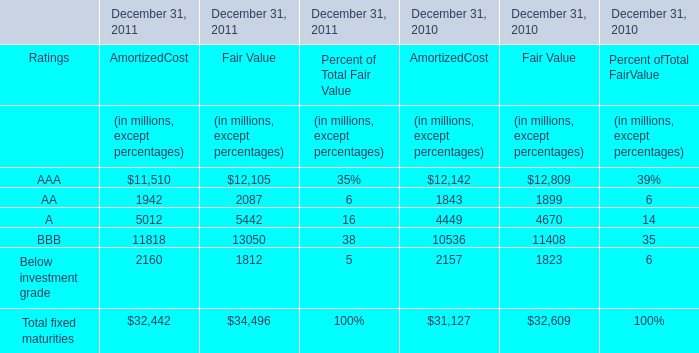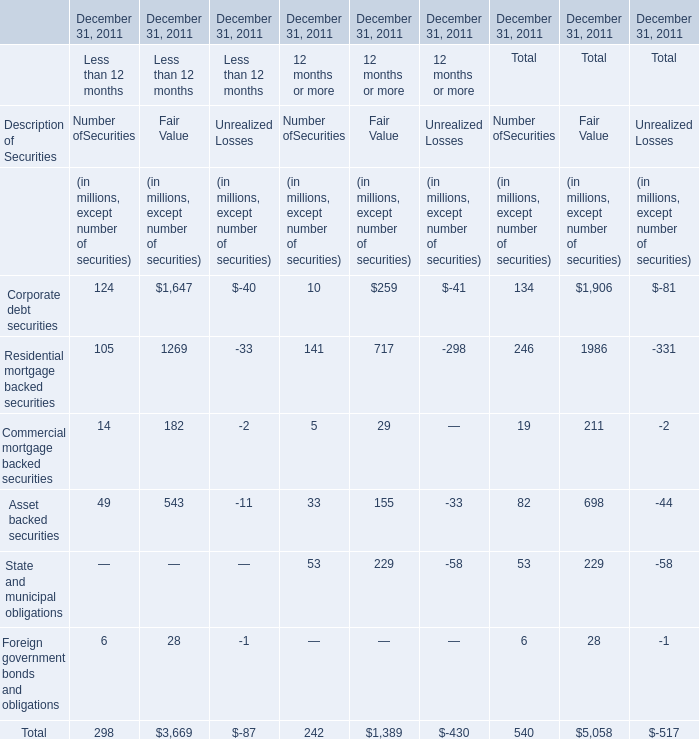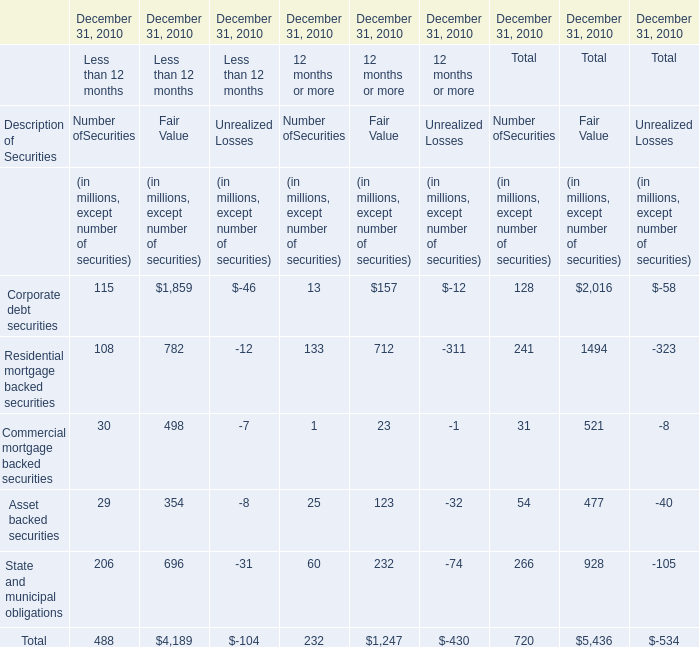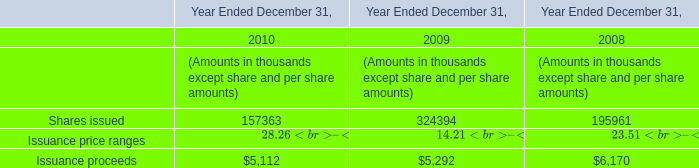What's the average of AmortizedCost of AAA in 2011 and 2010? (in million) 
Computations: ((11510 + 12142) / 2)
Answer: 11826.0. 